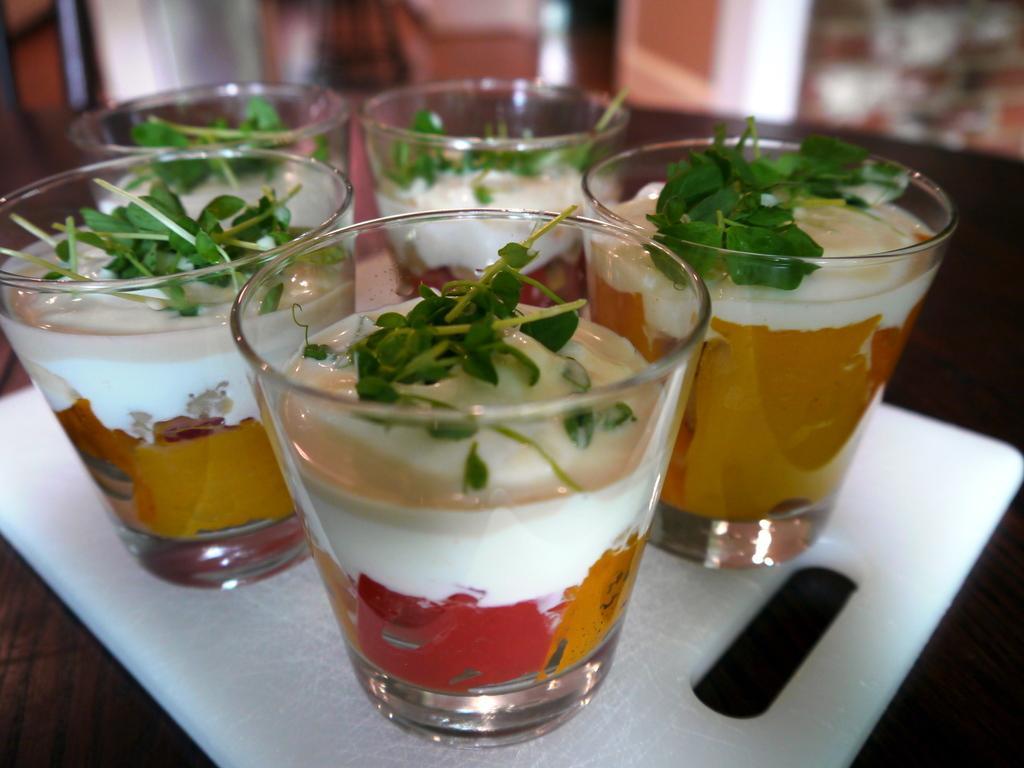Can you describe this image briefly? In the image there is a white tray. On the train there are glasses with white, red and yellow color cream and there are leaves on that cream. There is a blur image in the background. 